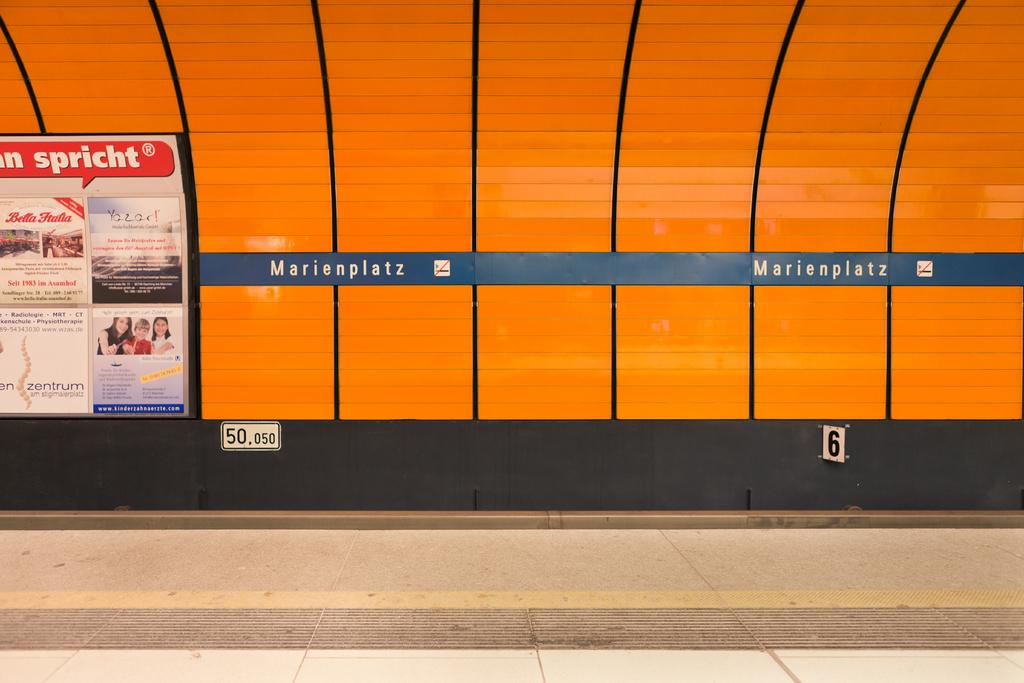What type of location is depicted in the image? The image contains a train station. What can be seen in the foreground of the image? There is a platform in the foreground of the image. Where is the hoarding located in the image? The hoarding is on the left side of the image. What type of insurance is advertised on the hoarding in the image? There is no advertisement or mention of insurance on the hoarding in the image. 